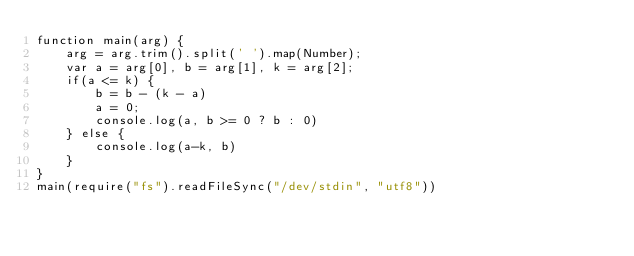Convert code to text. <code><loc_0><loc_0><loc_500><loc_500><_JavaScript_>function main(arg) {
	arg = arg.trim().split(' ').map(Number);
	var a = arg[0], b = arg[1], k = arg[2];
	if(a <= k) {
		b = b - (k - a)
		a = 0;
		console.log(a, b >= 0 ? b : 0)
	} else {
		console.log(a-k, b)
	}
}
main(require("fs").readFileSync("/dev/stdin", "utf8"))</code> 